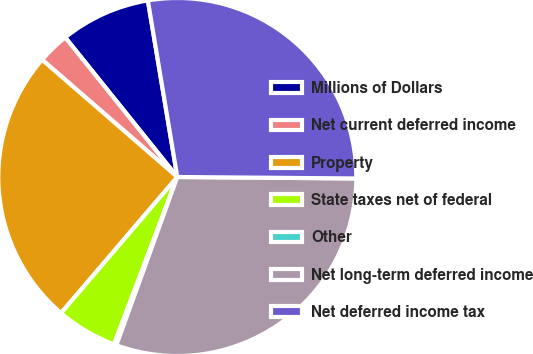Convert chart. <chart><loc_0><loc_0><loc_500><loc_500><pie_chart><fcel>Millions of Dollars<fcel>Net current deferred income<fcel>Property<fcel>State taxes net of federal<fcel>Other<fcel>Net long-term deferred income<fcel>Net deferred income tax<nl><fcel>8.14%<fcel>2.86%<fcel>25.12%<fcel>5.5%<fcel>0.22%<fcel>30.4%<fcel>27.76%<nl></chart> 